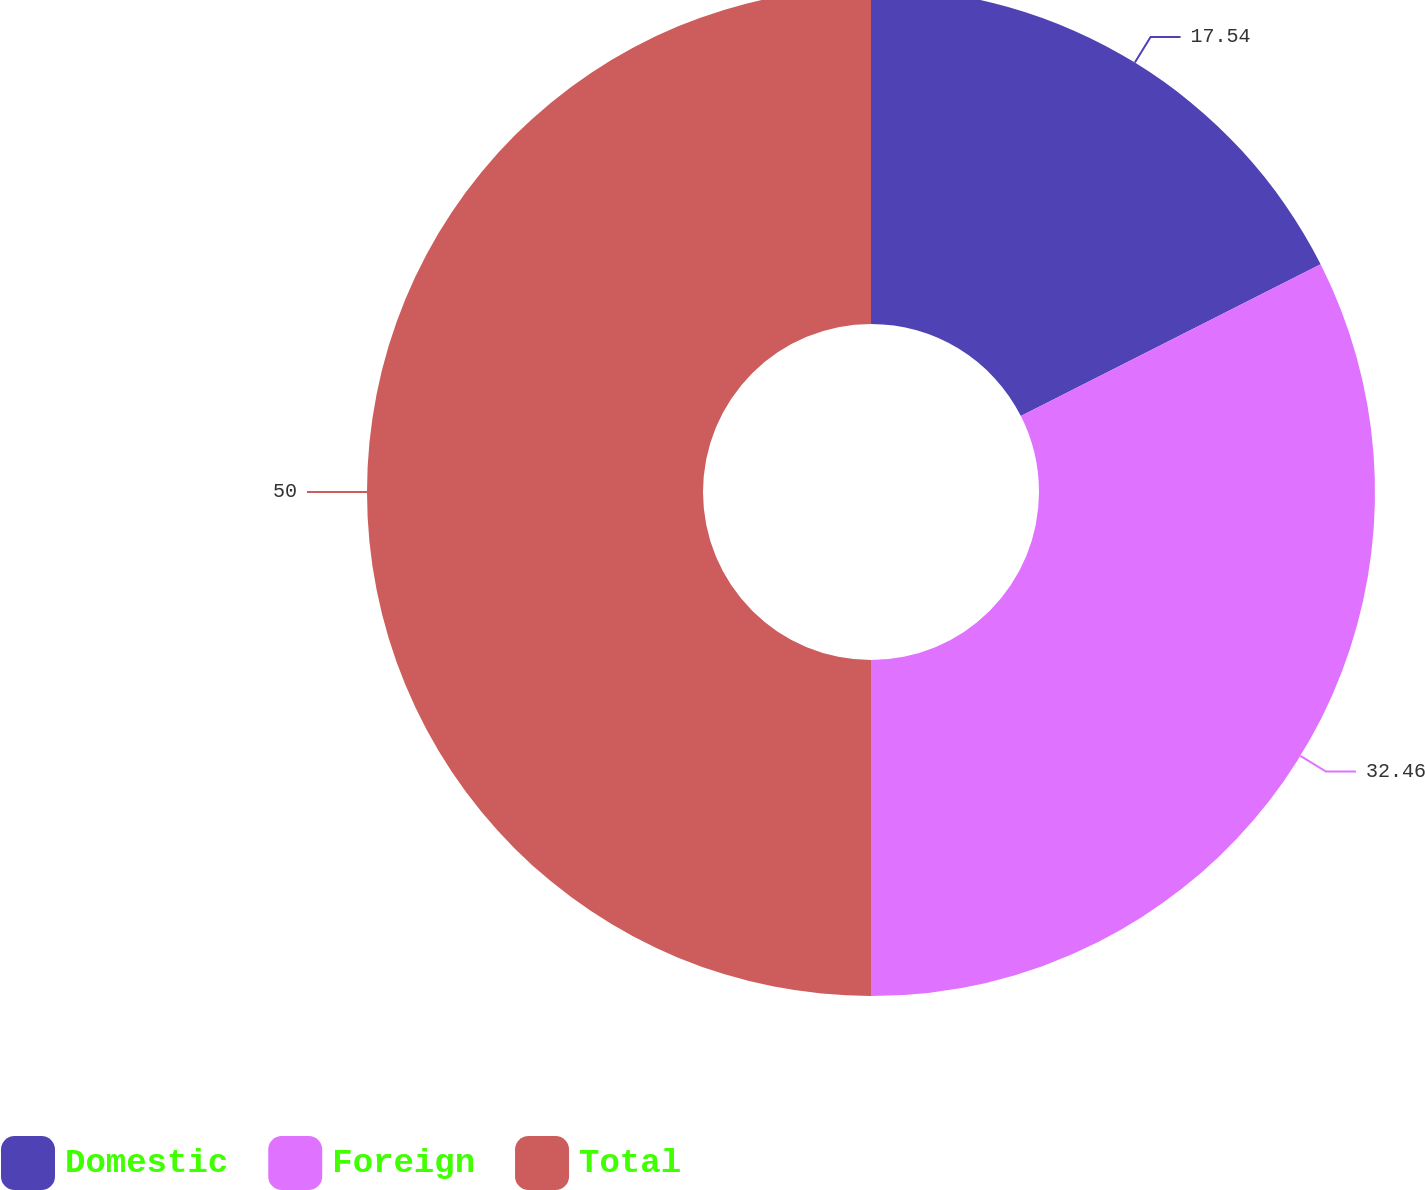<chart> <loc_0><loc_0><loc_500><loc_500><pie_chart><fcel>Domestic<fcel>Foreign<fcel>Total<nl><fcel>17.54%<fcel>32.46%<fcel>50.0%<nl></chart> 